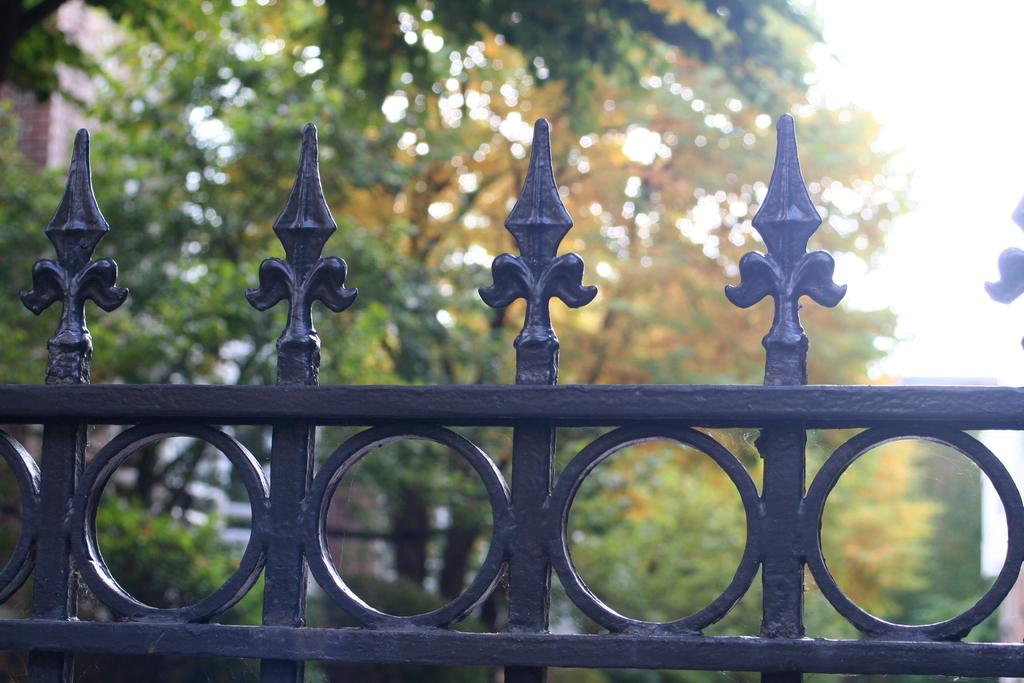What is located at the bottom of the image? There is a fencing gate at the bottom of the image. What can be seen in the background of the image? There are trees in the background of the image. What type of industry can be seen in the image? There is no industry present in the image; it features a fencing gate and trees in the background. Is there any blood visible in the image? There is no blood present in the image. 